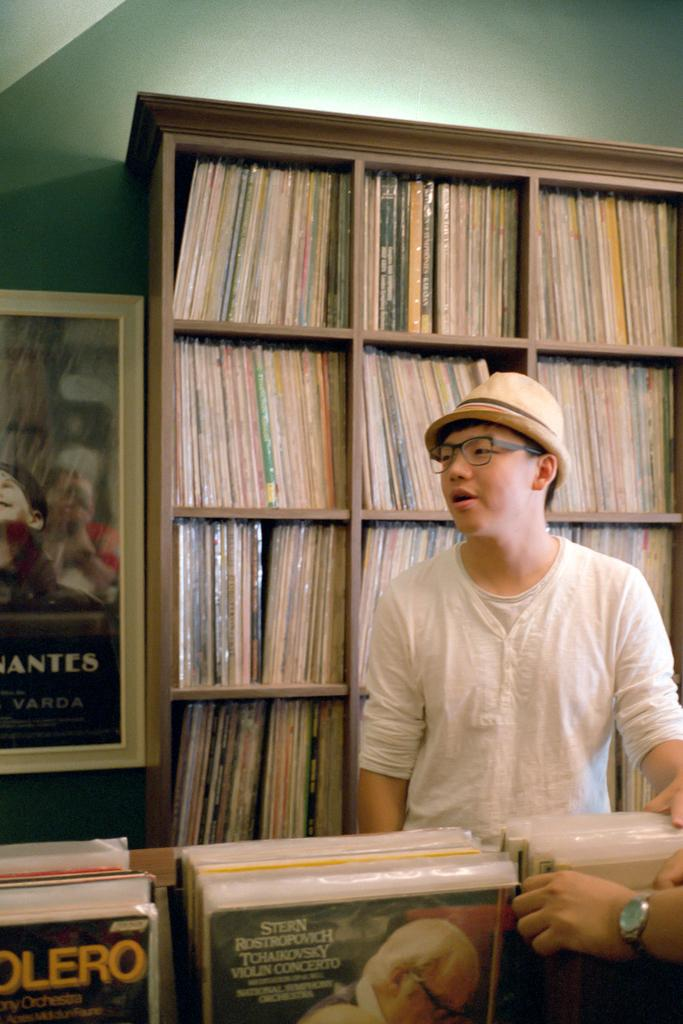<image>
Create a compact narrative representing the image presented. A man standing in front of shelves full of albums, one of the albums is a violin concerto. 